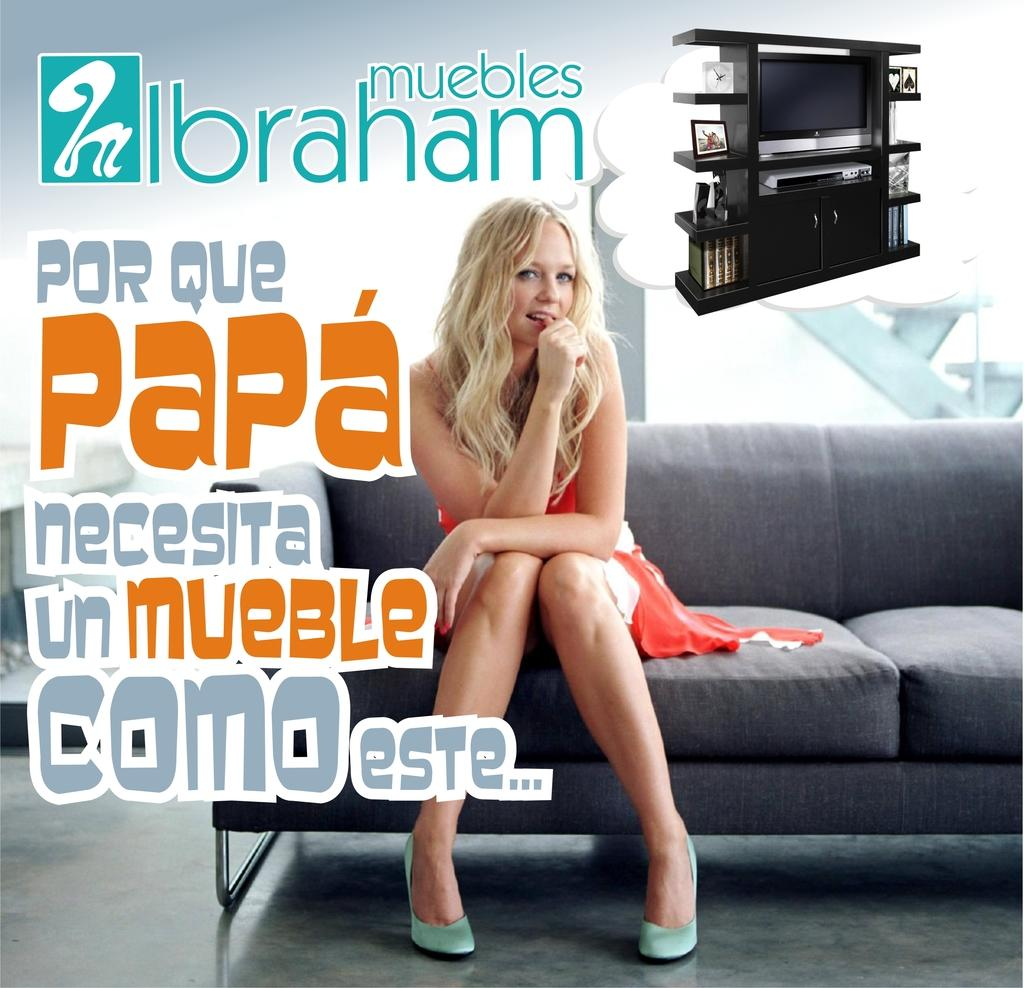<image>
Offer a succinct explanation of the picture presented. Ad showing a woman sitting on a couch with the words "muebles Ibraham" on top. 